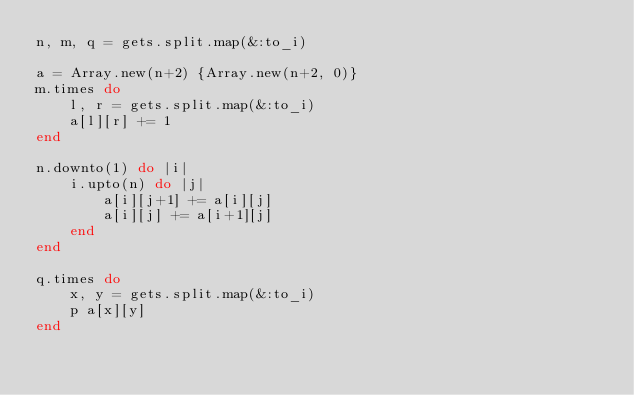Convert code to text. <code><loc_0><loc_0><loc_500><loc_500><_Ruby_>n, m, q = gets.split.map(&:to_i)

a = Array.new(n+2) {Array.new(n+2, 0)}
m.times do
    l, r = gets.split.map(&:to_i)
    a[l][r] += 1
end

n.downto(1) do |i|
    i.upto(n) do |j|
        a[i][j+1] += a[i][j]
        a[i][j] += a[i+1][j]
    end
end

q.times do
    x, y = gets.split.map(&:to_i)
    p a[x][y]
end</code> 